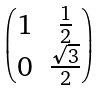Convert formula to latex. <formula><loc_0><loc_0><loc_500><loc_500>\begin{pmatrix} 1 & \frac { 1 } { 2 } \\ 0 & \frac { \sqrt { 3 } } { 2 } \end{pmatrix}</formula> 